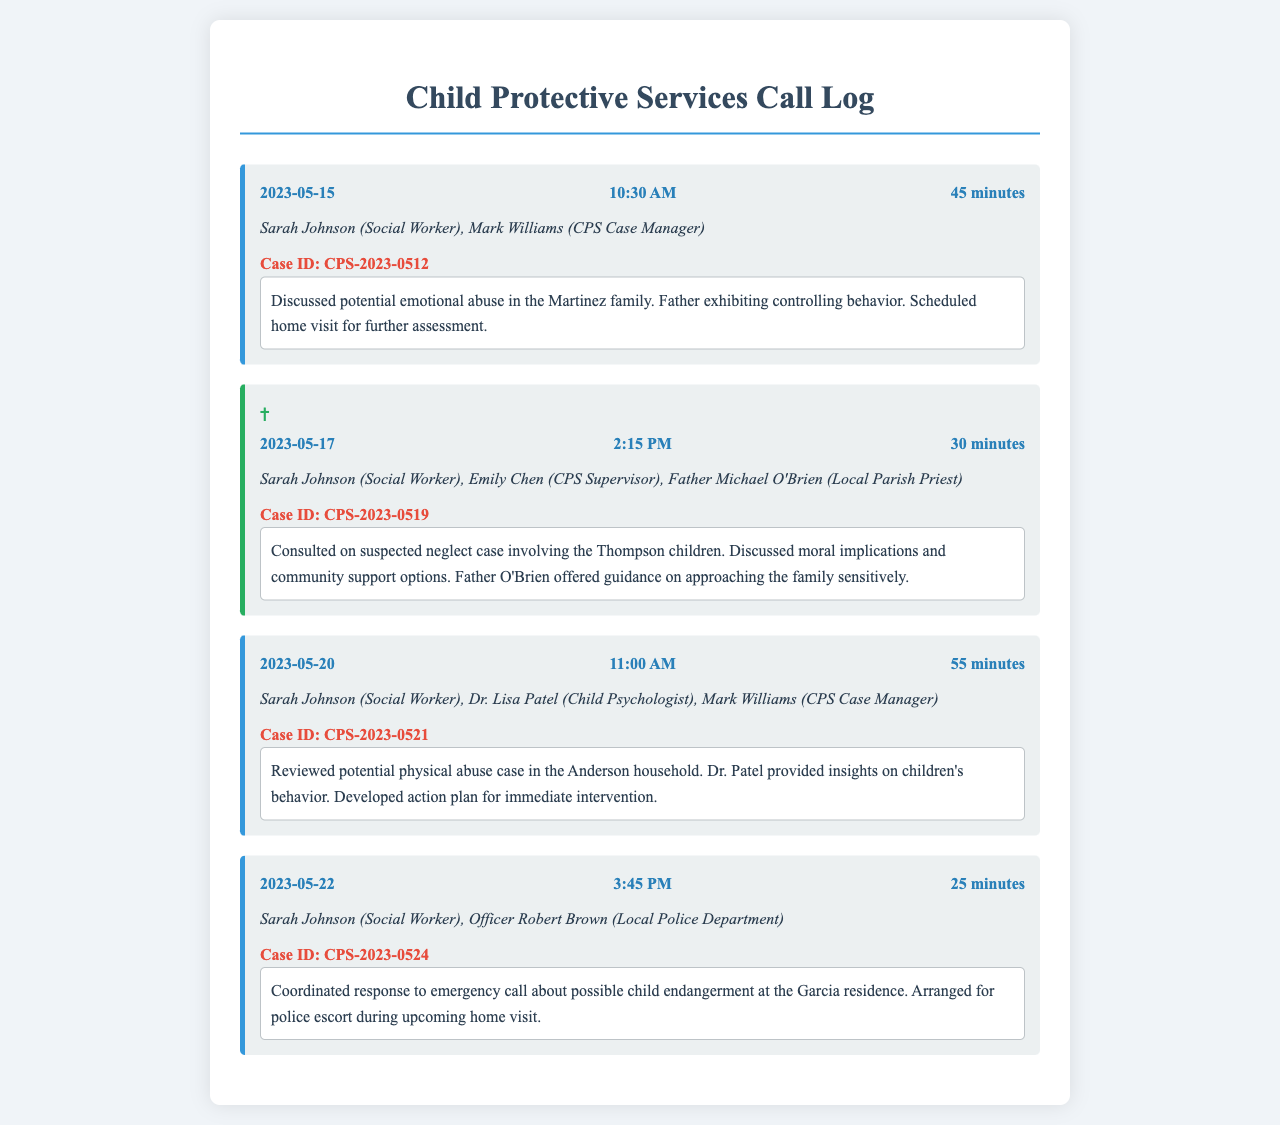What is the date of the first call? The first call is recorded on May 15, 2023.
Answer: May 15, 2023 Who participated in the call on May 17, 2023? The participants in the May 17, 2023 call include Sarah Johnson, Emily Chen, and Father Michael O'Brien.
Answer: Sarah Johnson, Emily Chen, Father Michael O'Brien What is the case ID for the potential physical abuse case? The case ID for the potential physical abuse case is CPS-2023-0521.
Answer: CPS-2023-0521 What was discussed during the call on May 22, 2023? The call on May 22, 2023 discussed coordinating a response to a possible child endangerment at the Garcia residence.
Answer: Coordinating response to possible child endangerment How long was the call on May 20, 2023? The duration of the call on May 20, 2023 was 55 minutes.
Answer: 55 minutes Which priest offered guidance during the case discussion? Father Michael O'Brien offered guidance regarding the case discussed on May 17, 2023.
Answer: Father Michael O'Brien What was the primary focus of the call on May 15, 2023? The primary focus was discussing potential emotional abuse in the Martinez family.
Answer: Potential emotional abuse in the Martinez family What type of abuse was reviewed on May 20, 2023? The type of abuse reviewed was potential physical abuse.
Answer: Potential physical abuse 